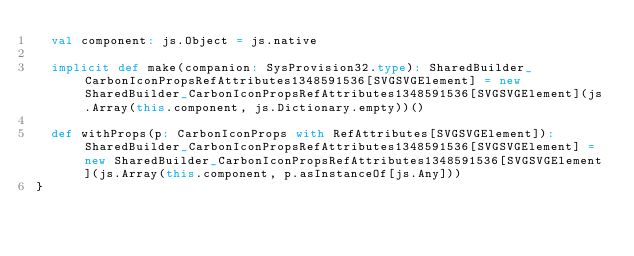<code> <loc_0><loc_0><loc_500><loc_500><_Scala_>  val component: js.Object = js.native
  
  implicit def make(companion: SysProvision32.type): SharedBuilder_CarbonIconPropsRefAttributes1348591536[SVGSVGElement] = new SharedBuilder_CarbonIconPropsRefAttributes1348591536[SVGSVGElement](js.Array(this.component, js.Dictionary.empty))()
  
  def withProps(p: CarbonIconProps with RefAttributes[SVGSVGElement]): SharedBuilder_CarbonIconPropsRefAttributes1348591536[SVGSVGElement] = new SharedBuilder_CarbonIconPropsRefAttributes1348591536[SVGSVGElement](js.Array(this.component, p.asInstanceOf[js.Any]))
}
</code> 